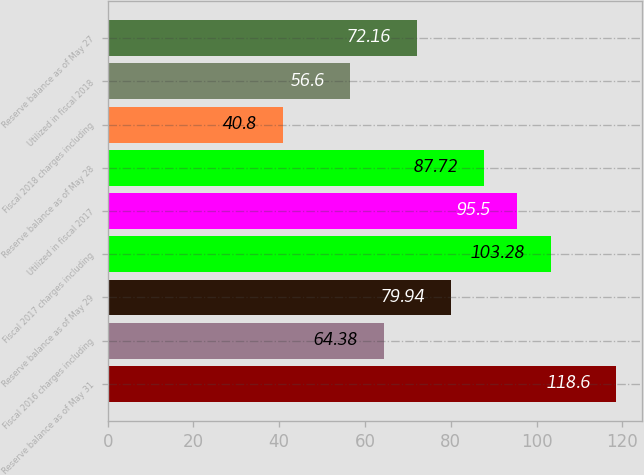Convert chart to OTSL. <chart><loc_0><loc_0><loc_500><loc_500><bar_chart><fcel>Reserve balance as of May 31<fcel>Fiscal 2016 charges including<fcel>Reserve balance as of May 29<fcel>Fiscal 2017 charges including<fcel>Utilized in fiscal 2017<fcel>Reserve balance as of May 28<fcel>Fiscal 2018 charges including<fcel>Utilized in fiscal 2018<fcel>Reserve balance as of May 27<nl><fcel>118.6<fcel>64.38<fcel>79.94<fcel>103.28<fcel>95.5<fcel>87.72<fcel>40.8<fcel>56.6<fcel>72.16<nl></chart> 